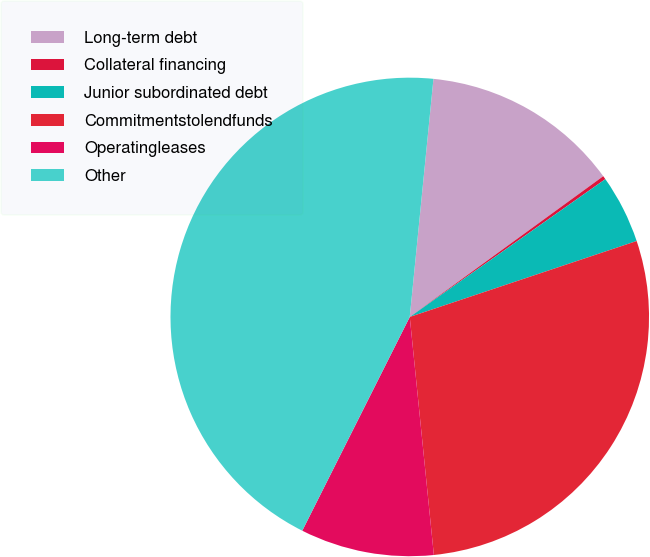<chart> <loc_0><loc_0><loc_500><loc_500><pie_chart><fcel>Long-term debt<fcel>Collateral financing<fcel>Junior subordinated debt<fcel>Commitmentstolendfunds<fcel>Operatingleases<fcel>Other<nl><fcel>13.41%<fcel>0.24%<fcel>4.63%<fcel>28.53%<fcel>9.02%<fcel>44.16%<nl></chart> 